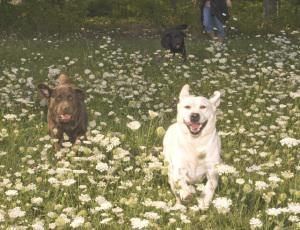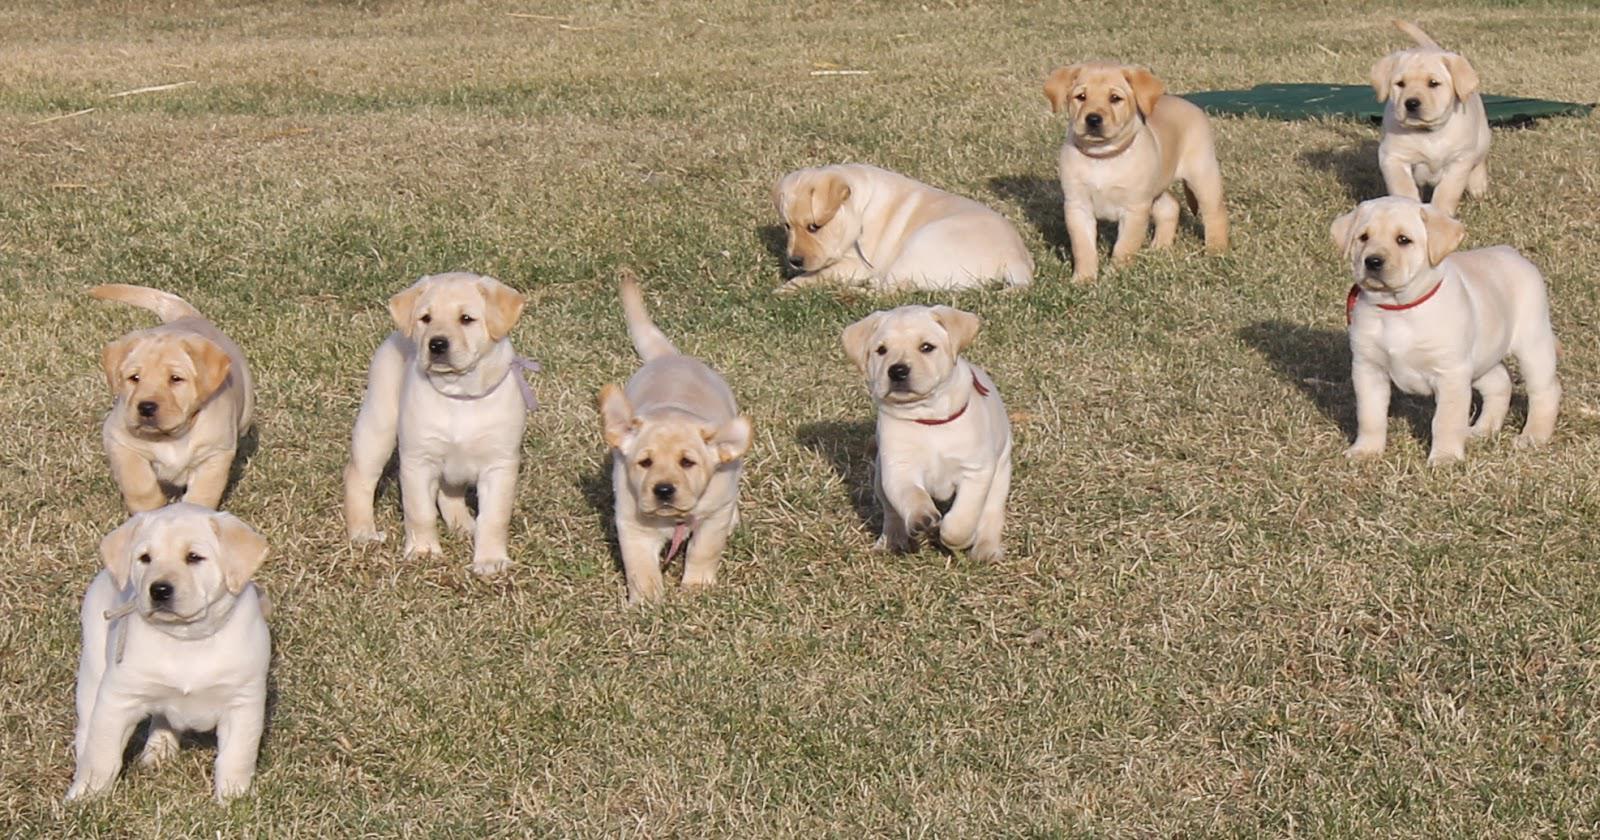The first image is the image on the left, the second image is the image on the right. Assess this claim about the two images: "There are no more than four labradors outside.". Correct or not? Answer yes or no. No. The first image is the image on the left, the second image is the image on the right. Examine the images to the left and right. Is the description "Left image shows one dog, which is solid brown and pictured outdoors." accurate? Answer yes or no. No. 